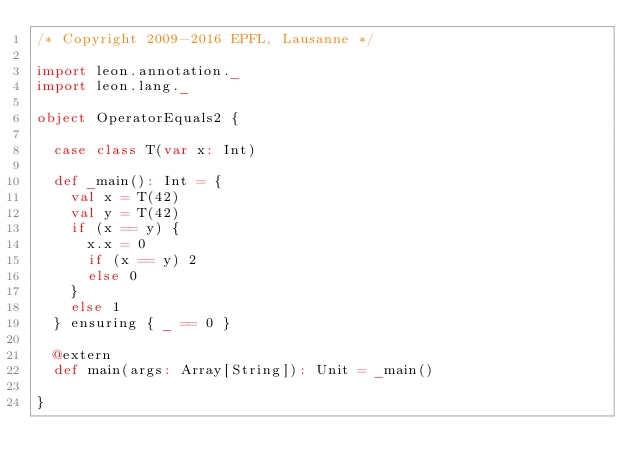<code> <loc_0><loc_0><loc_500><loc_500><_Scala_>/* Copyright 2009-2016 EPFL, Lausanne */

import leon.annotation._
import leon.lang._

object OperatorEquals2 {

  case class T(var x: Int)

  def _main(): Int = {
    val x = T(42)
    val y = T(42)
    if (x == y) {
      x.x = 0
      if (x == y) 2
      else 0
    }
    else 1
  } ensuring { _ == 0 }

  @extern
  def main(args: Array[String]): Unit = _main()

}

</code> 